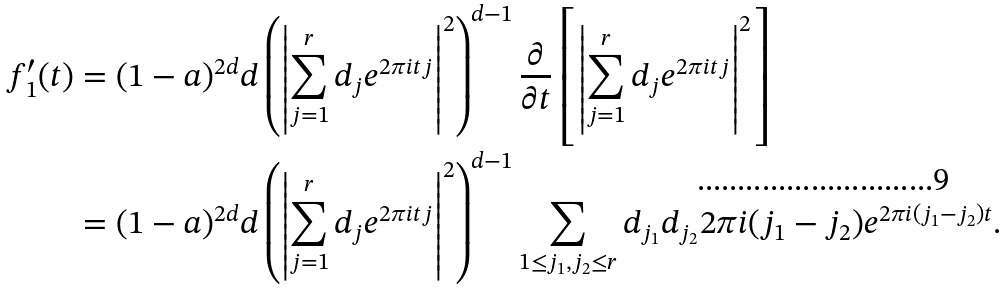<formula> <loc_0><loc_0><loc_500><loc_500>f _ { 1 } ^ { \prime } ( t ) & = ( 1 - a ) ^ { 2 d } d \left ( \left | \sum _ { j = 1 } ^ { r } d _ { j } e ^ { 2 \pi i t j } \right | ^ { 2 } \right ) ^ { d - 1 } \frac { \partial } { \partial t } \left [ \left | \sum _ { j = 1 } ^ { r } d _ { j } e ^ { 2 \pi i t j } \right | ^ { 2 } \right ] \\ & = ( 1 - a ) ^ { 2 d } d \left ( \left | \sum _ { j = 1 } ^ { r } d _ { j } e ^ { 2 \pi i t j } \right | ^ { 2 } \right ) ^ { d - 1 } \sum _ { 1 \leq j _ { 1 } , j _ { 2 } \leq r } d _ { j _ { 1 } } d _ { j _ { 2 } } 2 \pi i ( j _ { 1 } - j _ { 2 } ) e ^ { 2 \pi i ( j _ { 1 } - j _ { 2 } ) t } .</formula> 